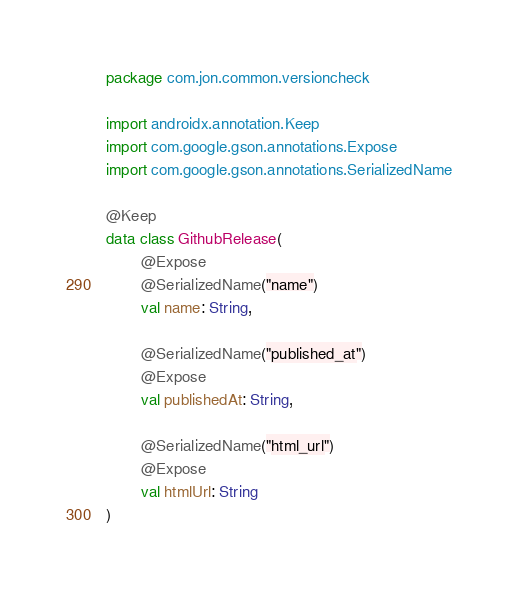Convert code to text. <code><loc_0><loc_0><loc_500><loc_500><_Kotlin_>package com.jon.common.versioncheck

import androidx.annotation.Keep
import com.google.gson.annotations.Expose
import com.google.gson.annotations.SerializedName

@Keep
data class GithubRelease(
        @Expose
        @SerializedName("name")
        val name: String,

        @SerializedName("published_at")
        @Expose
        val publishedAt: String,

        @SerializedName("html_url")
        @Expose
        val htmlUrl: String
)
</code> 